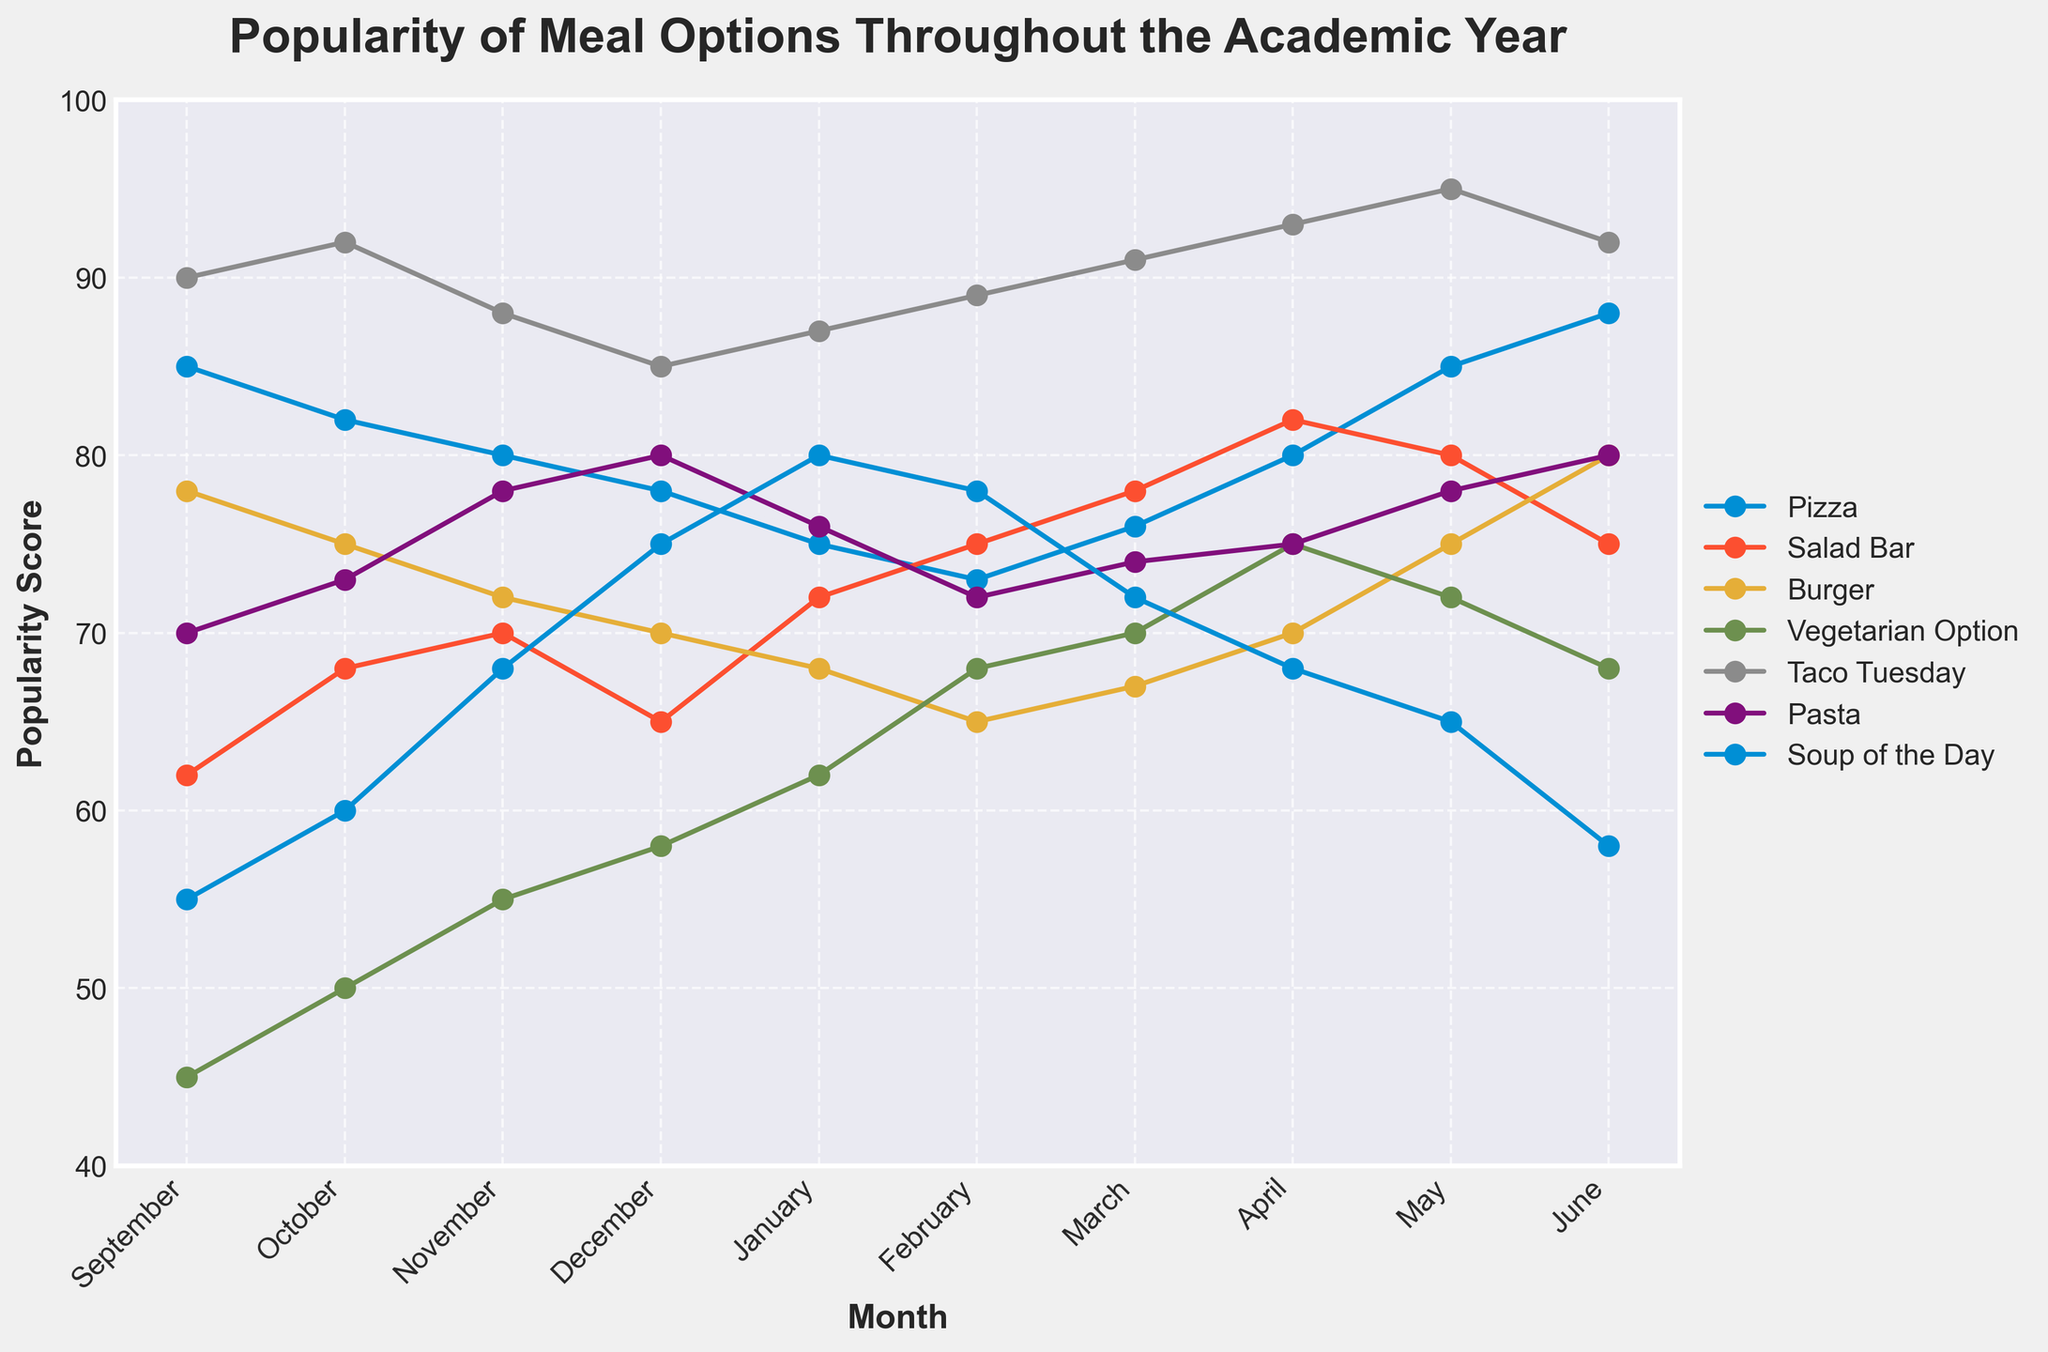What is the most popular meal option in March? First, identify the highest value among all meal options for the month of March on the y-axis. The highest value corresponds to Taco Tuesday with a score of 91.
Answer: Taco Tuesday Which meal option shows the greatest increase in popularity from September to June? Compare the values for each meal option between September and June. The Soup of the Day increases from 55 to 58, showing a small change, while others like Salad Bar and Pizza show larger increases. The greatest is Pizza, which rises from 85 to 88.
Answer: Pizza In which month is the popularity of the Vegetarian Option the highest? Look at the line corresponding to the Vegetarian Option and find the peak point on the graph. For Vegetarian Option, the highest popularity is in April, with a score of 75.
Answer: April How does the popularity of the Soup of the Day change from January to June? Compare the values for the Soup of the Day in January (80) and in June (58). The popularity decreases from 80 to 58.
Answer: Decreases Which meal option has the most stable popularity throughout the academic year? Examine the lines for each meal option and note which line has the least fluctuation. Salad Bar shows a consistent trend with moderate increases and decreases.
Answer: Salad Bar What is the combined popularity of Burger and Pasta in December? Add the values for Burger (70) and Pasta (80) in December. The combined value is 70 + 80 = 150.
Answer: 150 By how much does the popularity of Taco Tuesday in June exceed that in February? Subtract the popularity of Taco Tuesday in February (89) from that in June (92). The difference is 92 - 89 = 3.
Answer: 3 Which month sees the highest average popularity across all meal options? Calculate the average popularity for each month. June has the highest average popularity: (88 + 75 + 80 + 68 + 92 + 80 + 58) / 7 = 77.
Answer: June Compare the popularity of the Salad Bar and Pizza in April. Which one is more popular and by how much? Identify the values for Salad Bar (82) and Pizza (80) in April. Subtract the popularity of Pizza from Salad Bar: 82 - 80 = 2. Salad Bar is more popular by 2 units.
Answer: Salad Bar; 2 